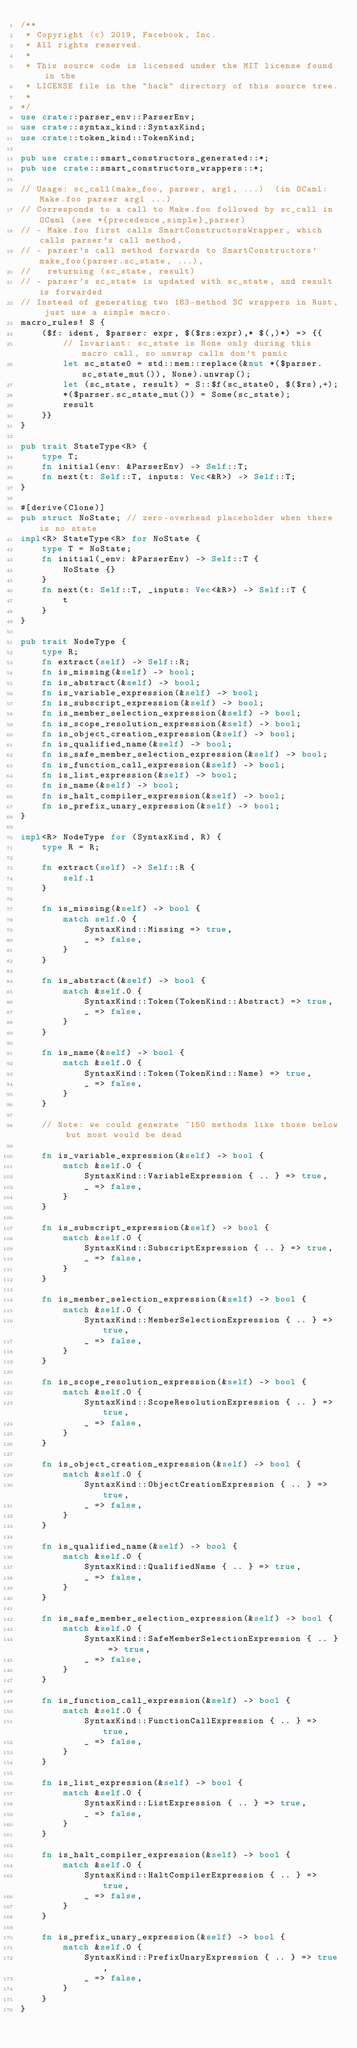Convert code to text. <code><loc_0><loc_0><loc_500><loc_500><_Rust_>/**
 * Copyright (c) 2019, Facebook, Inc.
 * All rights reserved.
 *
 * This source code is licensed under the MIT license found in the
 * LICENSE file in the "hack" directory of this source tree.
 *
*/
use crate::parser_env::ParserEnv;
use crate::syntax_kind::SyntaxKind;
use crate::token_kind::TokenKind;

pub use crate::smart_constructors_generated::*;
pub use crate::smart_constructors_wrappers::*;

// Usage: sc_call(make_foo, parser, arg1, ...)  (in OCaml: Make.foo parser arg1 ...)
// Corresponds to a call to Make.foo followed by sc_call in OCaml (see *{precedence,simple}_parser)
// - Make.foo first calls SmartConstructorsWrapper, which calls parser's call method,
// - parser's call method forwards to SmartConstructors' make_foo(parser.sc_state, ...),
//   returning (sc_state, result)
// - parser's sc_state is updated with sc_state, and result is forwarded
// Instead of generating two 183-method SC wrappers in Rust, just use a simple macro.
macro_rules! S {
    ($f: ident, $parser: expr, $($rs:expr),* $(,)*) => {{
        // Invariant: sc_state is None only during this macro call, so unwrap calls don't panic
        let sc_state0 = std::mem::replace(&mut *($parser.sc_state_mut()), None).unwrap();
        let (sc_state, result) = S::$f(sc_state0, $($rs),+);
        *($parser.sc_state_mut()) = Some(sc_state);
        result
    }}
}

pub trait StateType<R> {
    type T;
    fn initial(env: &ParserEnv) -> Self::T;
    fn next(t: Self::T, inputs: Vec<&R>) -> Self::T;
}

#[derive(Clone)]
pub struct NoState; // zero-overhead placeholder when there is no state
impl<R> StateType<R> for NoState {
    type T = NoState;
    fn initial(_env: &ParserEnv) -> Self::T {
        NoState {}
    }
    fn next(t: Self::T, _inputs: Vec<&R>) -> Self::T {
        t
    }
}

pub trait NodeType {
    type R;
    fn extract(self) -> Self::R;
    fn is_missing(&self) -> bool;
    fn is_abstract(&self) -> bool;
    fn is_variable_expression(&self) -> bool;
    fn is_subscript_expression(&self) -> bool;
    fn is_member_selection_expression(&self) -> bool;
    fn is_scope_resolution_expression(&self) -> bool;
    fn is_object_creation_expression(&self) -> bool;
    fn is_qualified_name(&self) -> bool;
    fn is_safe_member_selection_expression(&self) -> bool;
    fn is_function_call_expression(&self) -> bool;
    fn is_list_expression(&self) -> bool;
    fn is_name(&self) -> bool;
    fn is_halt_compiler_expression(&self) -> bool;
    fn is_prefix_unary_expression(&self) -> bool;
}

impl<R> NodeType for (SyntaxKind, R) {
    type R = R;

    fn extract(self) -> Self::R {
        self.1
    }

    fn is_missing(&self) -> bool {
        match self.0 {
            SyntaxKind::Missing => true,
            _ => false,
        }
    }

    fn is_abstract(&self) -> bool {
        match &self.0 {
            SyntaxKind::Token(TokenKind::Abstract) => true,
            _ => false,
        }
    }

    fn is_name(&self) -> bool {
        match &self.0 {
            SyntaxKind::Token(TokenKind::Name) => true,
            _ => false,
        }
    }

    // Note: we could generate ~150 methods like those below but most would be dead

    fn is_variable_expression(&self) -> bool {
        match &self.0 {
            SyntaxKind::VariableExpression { .. } => true,
            _ => false,
        }
    }

    fn is_subscript_expression(&self) -> bool {
        match &self.0 {
            SyntaxKind::SubscriptExpression { .. } => true,
            _ => false,
        }
    }

    fn is_member_selection_expression(&self) -> bool {
        match &self.0 {
            SyntaxKind::MemberSelectionExpression { .. } => true,
            _ => false,
        }
    }

    fn is_scope_resolution_expression(&self) -> bool {
        match &self.0 {
            SyntaxKind::ScopeResolutionExpression { .. } => true,
            _ => false,
        }
    }

    fn is_object_creation_expression(&self) -> bool {
        match &self.0 {
            SyntaxKind::ObjectCreationExpression { .. } => true,
            _ => false,
        }
    }

    fn is_qualified_name(&self) -> bool {
        match &self.0 {
            SyntaxKind::QualifiedName { .. } => true,
            _ => false,
        }
    }

    fn is_safe_member_selection_expression(&self) -> bool {
        match &self.0 {
            SyntaxKind::SafeMemberSelectionExpression { .. } => true,
            _ => false,
        }
    }

    fn is_function_call_expression(&self) -> bool {
        match &self.0 {
            SyntaxKind::FunctionCallExpression { .. } => true,
            _ => false,
        }
    }

    fn is_list_expression(&self) -> bool {
        match &self.0 {
            SyntaxKind::ListExpression { .. } => true,
            _ => false,
        }
    }

    fn is_halt_compiler_expression(&self) -> bool {
        match &self.0 {
            SyntaxKind::HaltCompilerExpression { .. } => true,
            _ => false,
        }
    }

    fn is_prefix_unary_expression(&self) -> bool {
        match &self.0 {
            SyntaxKind::PrefixUnaryExpression { .. } => true,
            _ => false,
        }
    }
}
</code> 